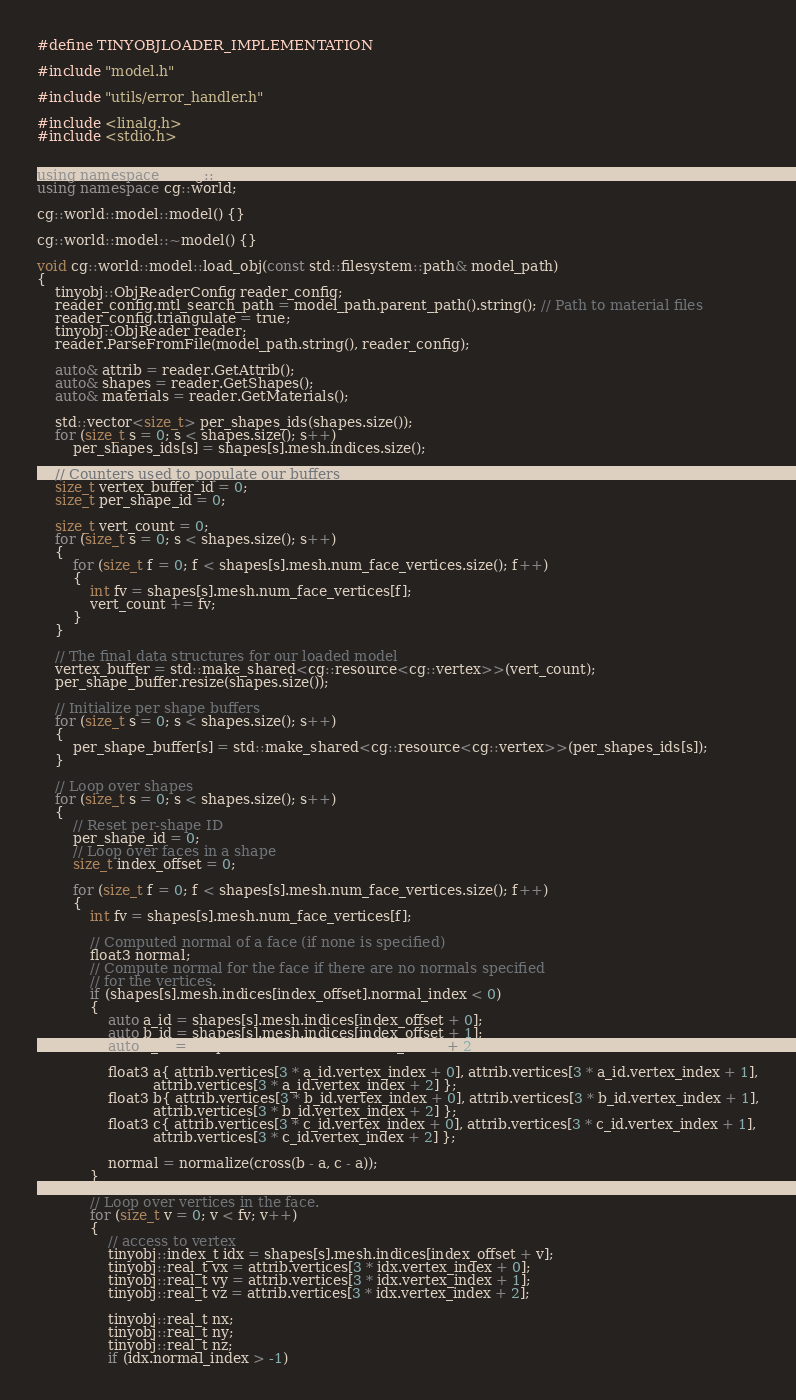<code> <loc_0><loc_0><loc_500><loc_500><_C++_>#define TINYOBJLOADER_IMPLEMENTATION

#include "model.h"

#include "utils/error_handler.h"

#include <linalg.h>
#include <stdio.h>


using namespace linalg::aliases;
using namespace cg::world;

cg::world::model::model() {}

cg::world::model::~model() {}

void cg::world::model::load_obj(const std::filesystem::path& model_path)
{
    tinyobj::ObjReaderConfig reader_config;
    reader_config.mtl_search_path = model_path.parent_path().string(); // Path to material files
    reader_config.triangulate = true;
    tinyobj::ObjReader reader;
    reader.ParseFromFile(model_path.string(), reader_config);

    auto& attrib = reader.GetAttrib();
    auto& shapes = reader.GetShapes();
    auto& materials = reader.GetMaterials();

    std::vector<size_t> per_shapes_ids(shapes.size());
    for (size_t s = 0; s < shapes.size(); s++)
        per_shapes_ids[s] = shapes[s].mesh.indices.size();

    // Counters used to populate our buffers
    size_t vertex_buffer_id = 0;
    size_t per_shape_id = 0;

    size_t vert_count = 0;
    for (size_t s = 0; s < shapes.size(); s++)
    {
        for (size_t f = 0; f < shapes[s].mesh.num_face_vertices.size(); f++)
        {
            int fv = shapes[s].mesh.num_face_vertices[f];
            vert_count += fv;
        }
    }

    // The final data structures for our loaded model
    vertex_buffer = std::make_shared<cg::resource<cg::vertex>>(vert_count);
    per_shape_buffer.resize(shapes.size());

    // Initialize per shape buffers
    for (size_t s = 0; s < shapes.size(); s++)
    {
        per_shape_buffer[s] = std::make_shared<cg::resource<cg::vertex>>(per_shapes_ids[s]);
    }

    // Loop over shapes
    for (size_t s = 0; s < shapes.size(); s++)
    {
        // Reset per-shape ID
        per_shape_id = 0;
        // Loop over faces in a shape
        size_t index_offset = 0;

        for (size_t f = 0; f < shapes[s].mesh.num_face_vertices.size(); f++)
        {
            int fv = shapes[s].mesh.num_face_vertices[f];

            // Computed normal of a face (if none is specified)
            float3 normal;
            // Compute normal for the face if there are no normals specified
            // for the vertices.
            if (shapes[s].mesh.indices[index_offset].normal_index < 0)
            {
                auto a_id = shapes[s].mesh.indices[index_offset + 0];
                auto b_id = shapes[s].mesh.indices[index_offset + 1];
                auto c_id = shapes[s].mesh.indices[index_offset + 2];

                float3 a{ attrib.vertices[3 * a_id.vertex_index + 0], attrib.vertices[3 * a_id.vertex_index + 1],
                          attrib.vertices[3 * a_id.vertex_index + 2] };
                float3 b{ attrib.vertices[3 * b_id.vertex_index + 0], attrib.vertices[3 * b_id.vertex_index + 1],
                          attrib.vertices[3 * b_id.vertex_index + 2] };
                float3 c{ attrib.vertices[3 * c_id.vertex_index + 0], attrib.vertices[3 * c_id.vertex_index + 1],
                          attrib.vertices[3 * c_id.vertex_index + 2] };

                normal = normalize(cross(b - a, c - a));
            }

            // Loop over vertices in the face.
            for (size_t v = 0; v < fv; v++)
            {
                // access to vertex
                tinyobj::index_t idx = shapes[s].mesh.indices[index_offset + v];
                tinyobj::real_t vx = attrib.vertices[3 * idx.vertex_index + 0];
                tinyobj::real_t vy = attrib.vertices[3 * idx.vertex_index + 1];
                tinyobj::real_t vz = attrib.vertices[3 * idx.vertex_index + 2];

                tinyobj::real_t nx;
                tinyobj::real_t ny;
                tinyobj::real_t nz;
                if (idx.normal_index > -1)</code> 